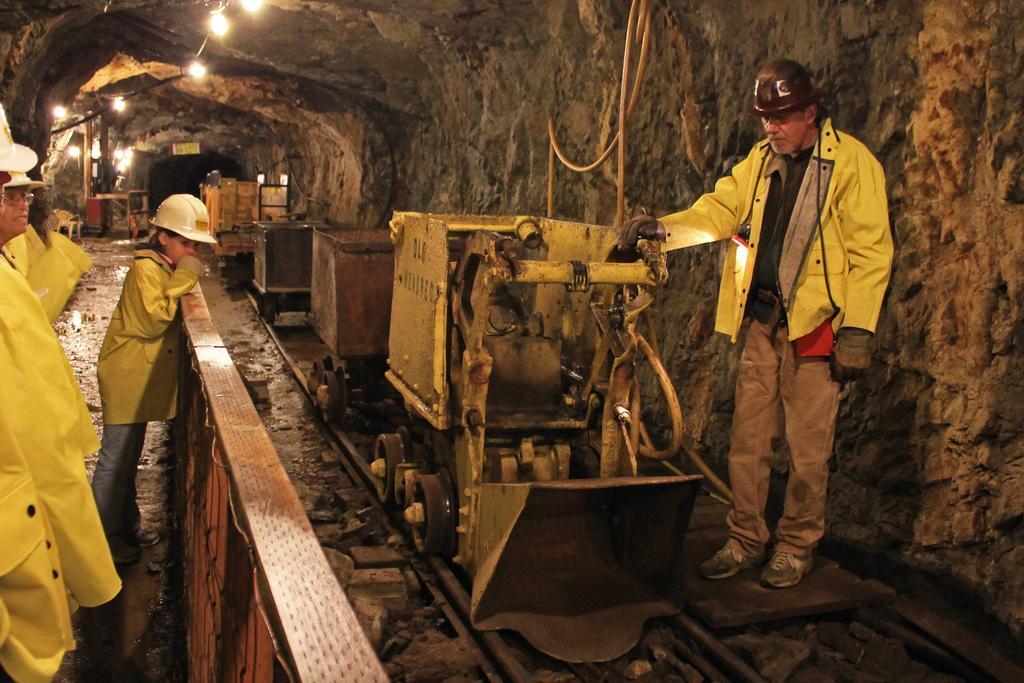Can you describe this image briefly? This image is taken under the ground mill, were we can see trucks on the railway track. Beside one fence is there. Near the fence people are standing by wearing helmet. To the right side of the image one man is standing wearing yellow color jacket and brown pant. Top of the image lights are present. 